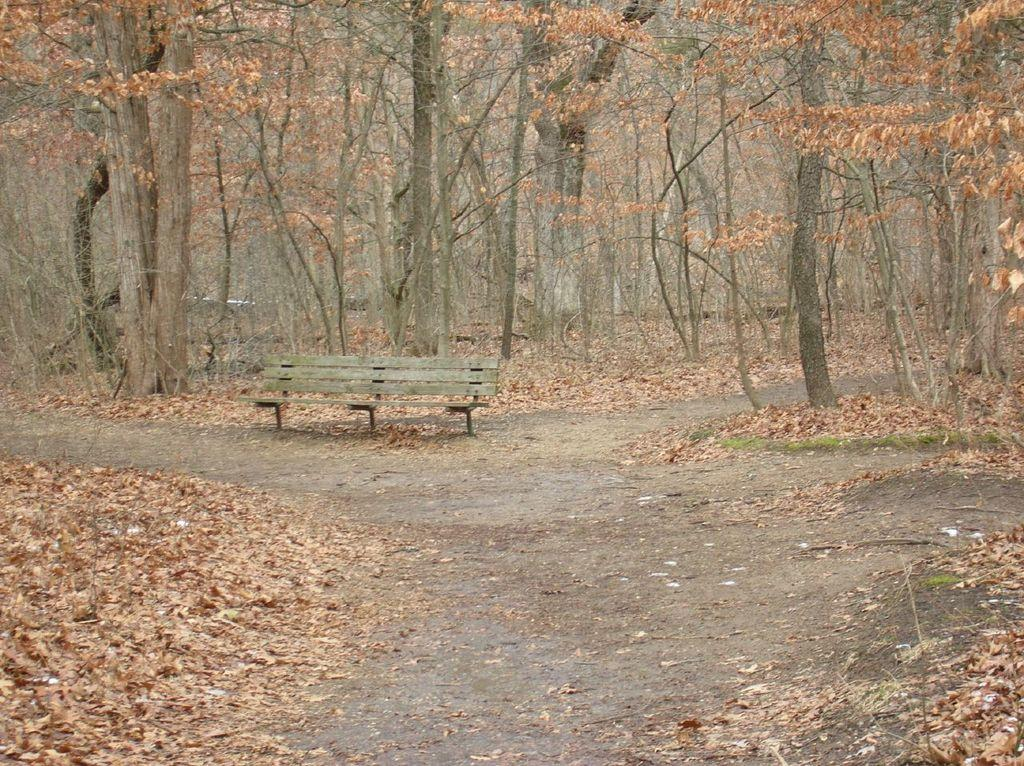What is the main object in the center of the image? There is a bench in the center of the image. What can be seen in the background of the image? There are trees in the background of the image. What is present on the ground at the bottom of the image? Leaves are present on the ground at the bottom of the image. What type of vest is the creature wearing in the image? There is no creature or vest present in the image. 